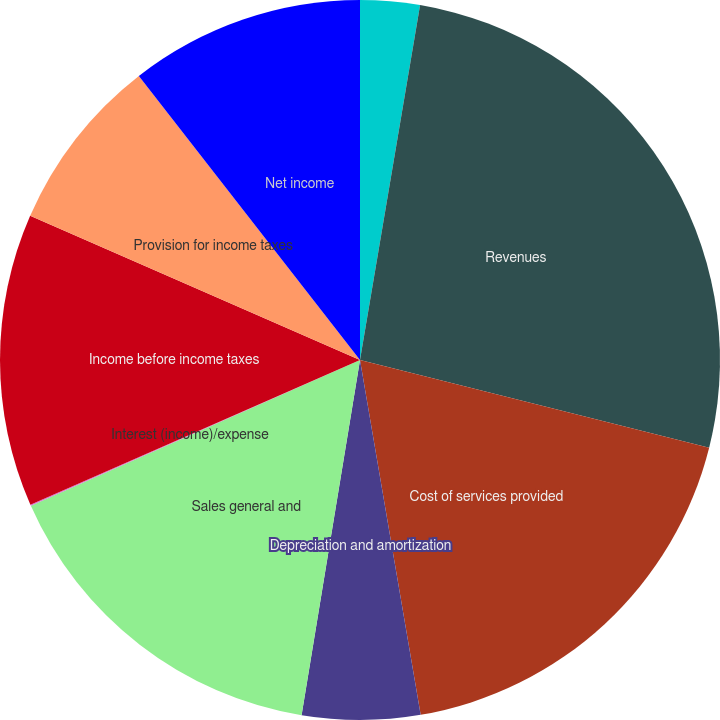Convert chart to OTSL. <chart><loc_0><loc_0><loc_500><loc_500><pie_chart><fcel>(in thousands)<fcel>Revenues<fcel>Cost of services provided<fcel>Depreciation and amortization<fcel>Sales general and<fcel>Interest (income)/expense<fcel>Income before income taxes<fcel>Provision for income taxes<fcel>Net income<nl><fcel>2.67%<fcel>26.25%<fcel>18.39%<fcel>5.29%<fcel>15.77%<fcel>0.05%<fcel>13.15%<fcel>7.91%<fcel>10.53%<nl></chart> 